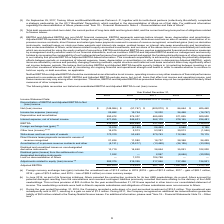According to Teekay Corporation's financial document, When did Altera canceled the construction contracts for its two UMS newbuildings? According to the financial document, June 2016. The relevant text states: "(b) In June 2016, as part of its financing initiatives, Altera canceled the construction contracts for its two UMS n..." Also, can you calculate: What is the change in Net (loss) income from Year Ended December 31, 2019 to December 31, 2018? Based on the calculation: -148,986-(-57,747), the result is -91239 (in thousands). This is based on the information: "Net (loss) income $ (148,986) $ (57,747) $ (529,072) $ 86,664 $ 405,460 Net (loss) income $ (148,986) $ (57,747) $ (529,072) $ 86,664 $ 405,460..." The key data points involved are: 148,986, 57,747. Also, can you calculate: What is the change in Income tax expense (recovery) from Year Ended December 31, 2019 to December 31, 2018? Based on the calculation: 25,482-19,724, the result is 5758 (in thousands). This is based on the information: "Income tax expense (recovery) 25,482 19,724 12,232 24,468 (16,767) Income tax expense (recovery) 25,482 19,724 12,232 24,468 (16,767)..." The key data points involved are: 19,724, 25,482. Additionally, In which years did the company recorded a net loss? The document contains multiple relevant values: 2019, 2018, 2017. Locate and analyze net (loss) income in row 5. From the document: "2019 2018 2017 2016 2015 2019 2018 2017 2016 2015 2019 2018 2017 2016 2015..." Also, What was the EBITDA value in 2019? According to the financial document, 438,423 (in thousands). The relevant text states: "EBITDA 438,423 483,885 231,099 961,102 1,134,674..." Also, What was the net loss provision in 2016? According to the financial document, $23.4 million. The relevant text states: "f the UMS newbuildings. This net loss provision of $23.4 million for the year ended December 31, 2016 was reported in other loss in our consolidated statement of inc..." 